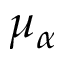<formula> <loc_0><loc_0><loc_500><loc_500>\mu _ { \alpha }</formula> 